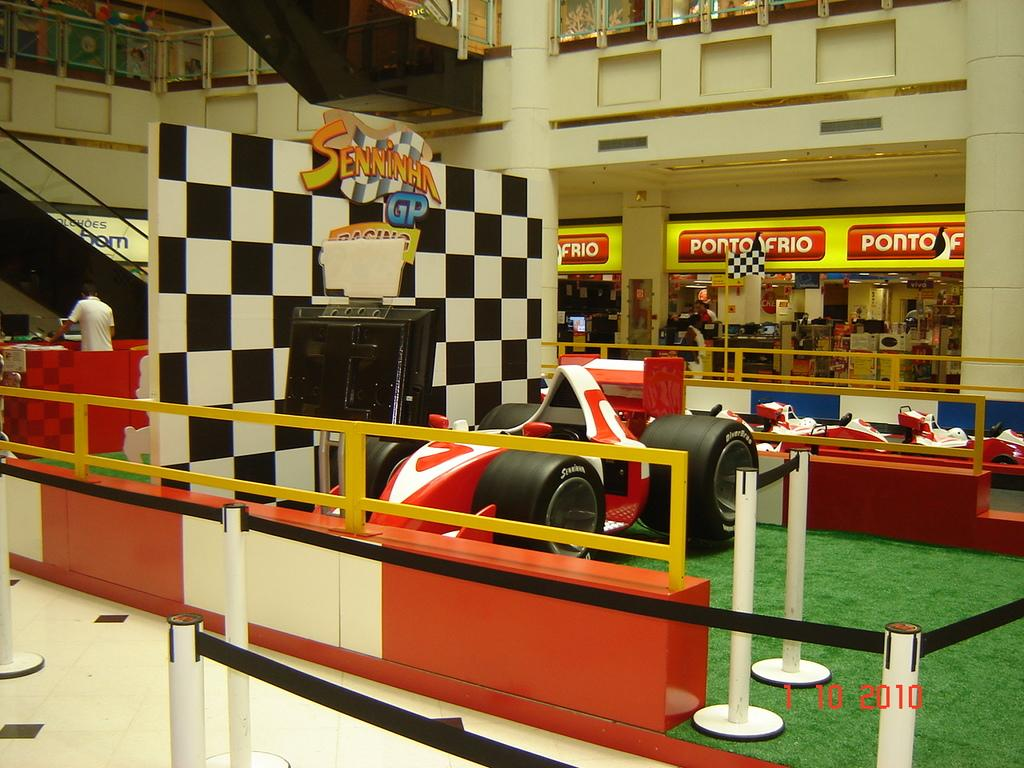What type of barrier can be seen in the image? There is a fence in the image. What type of vegetation is present in the image? There is grass in the image. What is the person standing in front of in the image? There is a monitor to stand in the image. What type of vehicles are visible in the image? There are sports cars in the image. What type of signage is present in the image? There are boards in the image. What is the person doing in the image? There is a person standing in the image. What type of transportation is available in the image? There is an escalator in the image. What type of commercial establishments are present in the image? There are stores in the image. What type of railing can be seen in the image? There is a glass railing in the image. What type of architectural feature is present in the image? There are stairs in the image. What can be seen in the background of the image? There is a wall in the background of the image. How many chairs are visible in the image? There are no chairs present in the image. What type of servant is attending to the person in the image? There is no servant present in the image. What type of vessel is being used to transport the sports cars in the image? There are no vessels present in the image, and the sports cars are not being transported. 